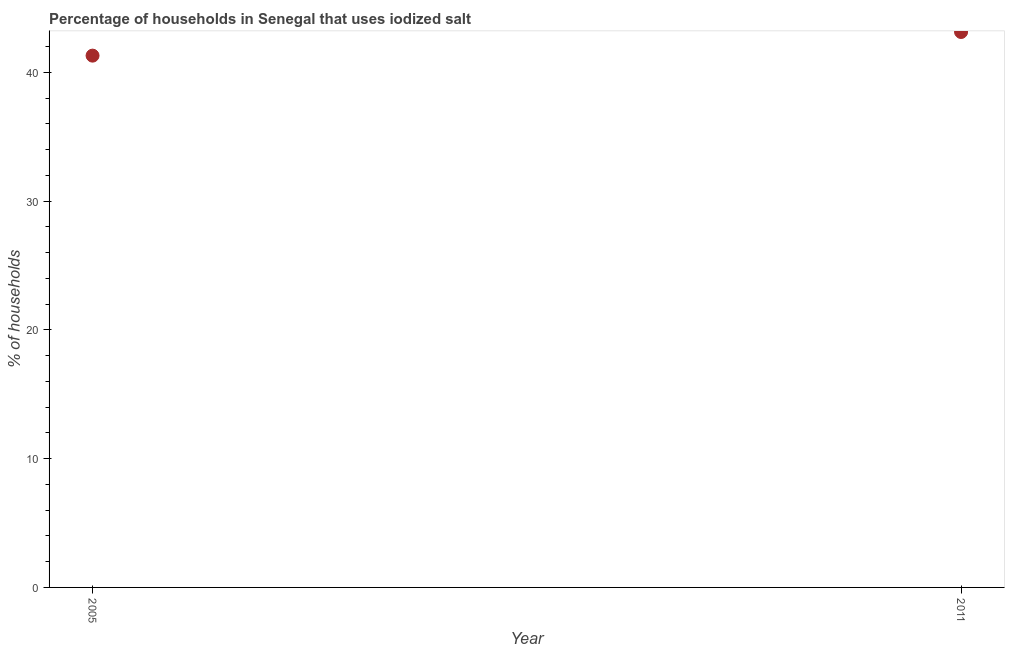What is the percentage of households where iodized salt is consumed in 2011?
Offer a terse response. 43.14. Across all years, what is the maximum percentage of households where iodized salt is consumed?
Offer a terse response. 43.14. Across all years, what is the minimum percentage of households where iodized salt is consumed?
Make the answer very short. 41.3. What is the sum of the percentage of households where iodized salt is consumed?
Give a very brief answer. 84.44. What is the difference between the percentage of households where iodized salt is consumed in 2005 and 2011?
Provide a short and direct response. -1.84. What is the average percentage of households where iodized salt is consumed per year?
Offer a very short reply. 42.22. What is the median percentage of households where iodized salt is consumed?
Your answer should be compact. 42.22. Do a majority of the years between 2005 and 2011 (inclusive) have percentage of households where iodized salt is consumed greater than 26 %?
Keep it short and to the point. Yes. What is the ratio of the percentage of households where iodized salt is consumed in 2005 to that in 2011?
Give a very brief answer. 0.96. Is the percentage of households where iodized salt is consumed in 2005 less than that in 2011?
Keep it short and to the point. Yes. How many dotlines are there?
Keep it short and to the point. 1. How many years are there in the graph?
Provide a short and direct response. 2. Are the values on the major ticks of Y-axis written in scientific E-notation?
Give a very brief answer. No. Does the graph contain grids?
Ensure brevity in your answer.  No. What is the title of the graph?
Offer a very short reply. Percentage of households in Senegal that uses iodized salt. What is the label or title of the X-axis?
Make the answer very short. Year. What is the label or title of the Y-axis?
Provide a succinct answer. % of households. What is the % of households in 2005?
Your answer should be very brief. 41.3. What is the % of households in 2011?
Give a very brief answer. 43.14. What is the difference between the % of households in 2005 and 2011?
Provide a short and direct response. -1.84. What is the ratio of the % of households in 2005 to that in 2011?
Provide a succinct answer. 0.96. 